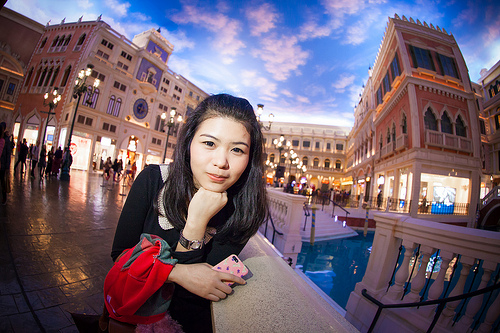<image>
Is the building behind the woman? Yes. From this viewpoint, the building is positioned behind the woman, with the woman partially or fully occluding the building. 